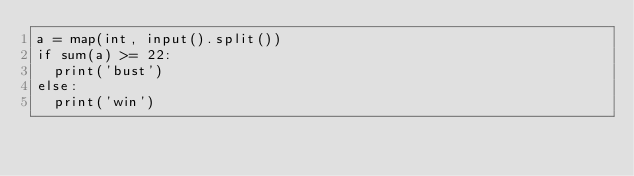<code> <loc_0><loc_0><loc_500><loc_500><_Python_>a = map(int, input().split())
if sum(a) >= 22:
  print('bust')
else:
  print('win')</code> 